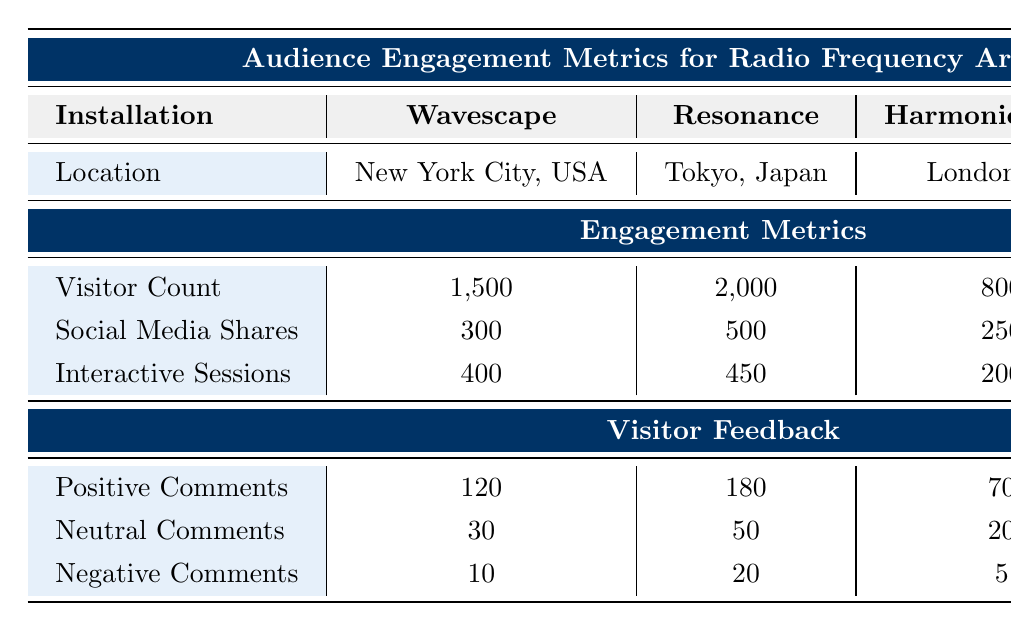What is the visitor count for the installation "Resonance"? The visitor count for "Resonance" is listed directly under the relevant section in the table, showing 2,000
Answer: 2,000 Which installation has the highest number of social media shares? By comparing the social media shares for each installation, "Resonance" has the highest with 500 shares
Answer: Resonance What is the total number of interactive sessions across all installations? To find the total, sum the interactive sessions: 400 (Wavescape) + 450 (Resonance) + 200 (Harmonic Vision) + 350 (Echoes of Light) = 1400
Answer: 1400 Do more visitors prefer the installation "Wavescape" over "Harmonic Vision"? Observing the visitor counts, "Wavescape" has 1,500 visitors while "Harmonic Vision" has 800, thus more visitors prefer "Wavescape"
Answer: Yes What is the average number of positive comments across all installations? To calculate the average positive comments: sum the positive comments (120 + 180 + 70 + 100) = 470, then divide by the number of installations (4), giving 470/4 = 117.5
Answer: 117.5 Which installation has the fewest negative comments? Examining the negative comments, "Harmonic Vision" and "Echoes of Light" both have 5 negative comments, which is the lowest in the table
Answer: Harmonic Vision and Echoes of Light If we rank the installations based on visitor feedback, which installation ranks first? By considering the number of positive comments, "Resonance" has the highest number of positive comments at 180, ranking it first
Answer: Resonance Are there more neutral comments for "Echoes of Light" than "Harmonic Vision"? Comparing the neutral comments, "Echoes of Light" has 15 neutral comments, while "Harmonic Vision" has 20, so "Harmonic Vision" has more
Answer: No 